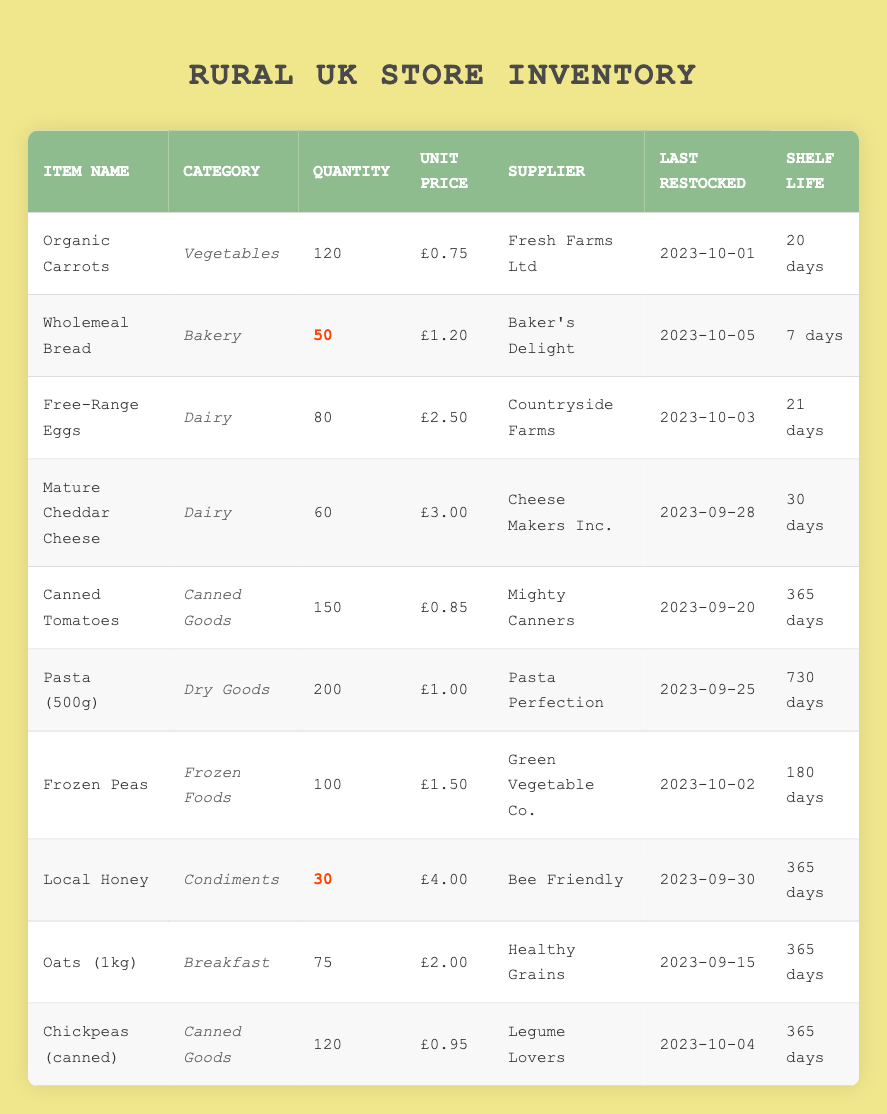What is the unit price of Organic Carrots? The unit price is specifically listed next to the item name "Organic Carrots" in the table, which shows a value of £0.75.
Answer: £0.75 How many Free-Range Eggs are currently in stock? The table indicates the quantity in stock for "Free-Range Eggs," which is found in the corresponding row showing a quantity of 80.
Answer: 80 Which item has the longest shelf life? To determine the longest shelf life, we can compare the "Shelf Life" column for all items. "Pasta (500g)" has the highest value of 730 days.
Answer: Pasta (500g) Is there more than one item with a low stock quantity? By checking the "Quantity" column, only "Wholemeal Bread" with 50 and "Local Honey" with 30 are marked with low stock. Since there are two items, the answer is yes.
Answer: Yes What is the total quantity of all canned goods in stock? The total quantity of canned goods is found by adding the quantities of "Canned Tomatoes" (150) and "Chickpeas (canned)" (120). The sum is 150 + 120 = 270.
Answer: 270 How many items were restocked most recently? Looking at the "Last Restocked" column, the items "Wholemeal Bread" (2023-10-05) and "Chickpeas (canned)" (2023-10-04) are the two most recently restocked items.
Answer: 2 What is the average unit price of the Dairy category items? The Dairy category includes "Free-Range Eggs" (£2.50) and "Mature Cheddar Cheese" (£3.00). The average unit price is calculated as (2.50 + 3.00) / 2 = £2.75.
Answer: £2.75 Which supplier provides the highest priced item? Reviewing the "Unit Price" column, "Local Honey" at £4.00 is the highest priced item, supplied by "Bee Friendly."
Answer: Local Honey Do any items have a shelf life of 365 days? Yes, if we check the "Shelf Life" column, "Canned Tomatoes," "Local Honey," "Oats (1kg)," and "Chickpeas (canned)" all show a shelf life of 365 days. Since there are multiple items, the answer is yes.
Answer: Yes What is the total stock quantity of all the items supplied by "Fresh Farms Ltd"? The only item supplied by "Fresh Farms Ltd" is "Organic Carrots" with a quantity of 120. Therefore, the total stock for that supplier is 120.
Answer: 120 